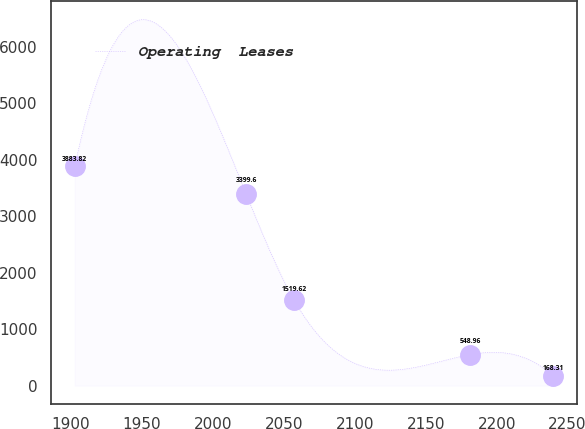Convert chart to OTSL. <chart><loc_0><loc_0><loc_500><loc_500><line_chart><ecel><fcel>Operating  Leases<nl><fcel>1902.55<fcel>3883.82<nl><fcel>2023.31<fcel>3399.6<nl><fcel>2057.06<fcel>1519.62<nl><fcel>2181.21<fcel>548.96<nl><fcel>2240.04<fcel>168.31<nl></chart> 